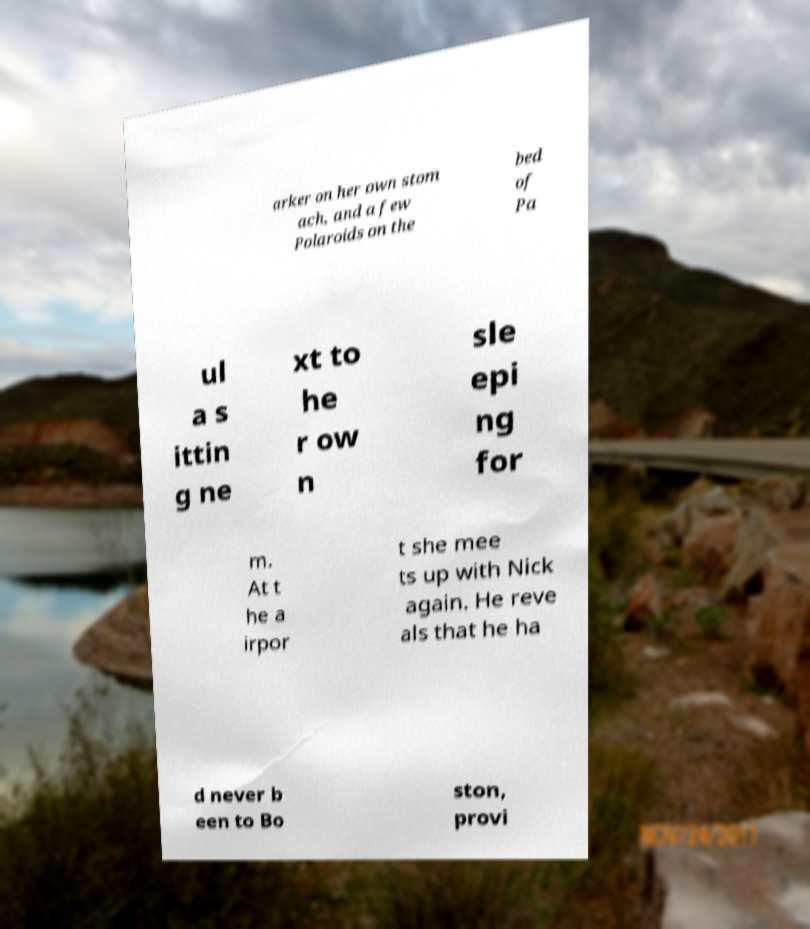Could you extract and type out the text from this image? arker on her own stom ach, and a few Polaroids on the bed of Pa ul a s ittin g ne xt to he r ow n sle epi ng for m. At t he a irpor t she mee ts up with Nick again. He reve als that he ha d never b een to Bo ston, provi 